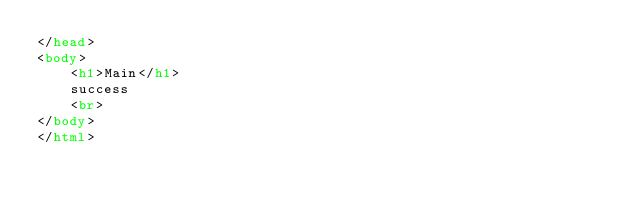Convert code to text. <code><loc_0><loc_0><loc_500><loc_500><_HTML_></head>
<body>
	<h1>Main</h1>
	success
	<br>
</body>
</html>


</code> 